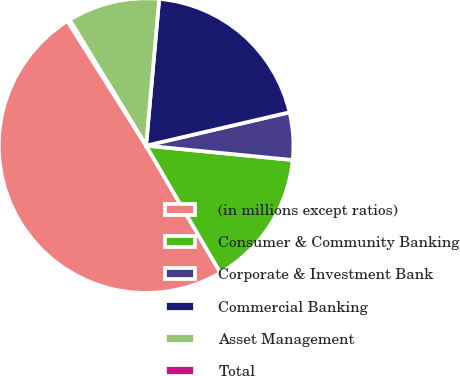Convert chart to OTSL. <chart><loc_0><loc_0><loc_500><loc_500><pie_chart><fcel>(in millions except ratios)<fcel>Consumer & Community Banking<fcel>Corporate & Investment Bank<fcel>Commercial Banking<fcel>Asset Management<fcel>Total<nl><fcel>49.46%<fcel>15.03%<fcel>5.19%<fcel>19.95%<fcel>10.11%<fcel>0.27%<nl></chart> 